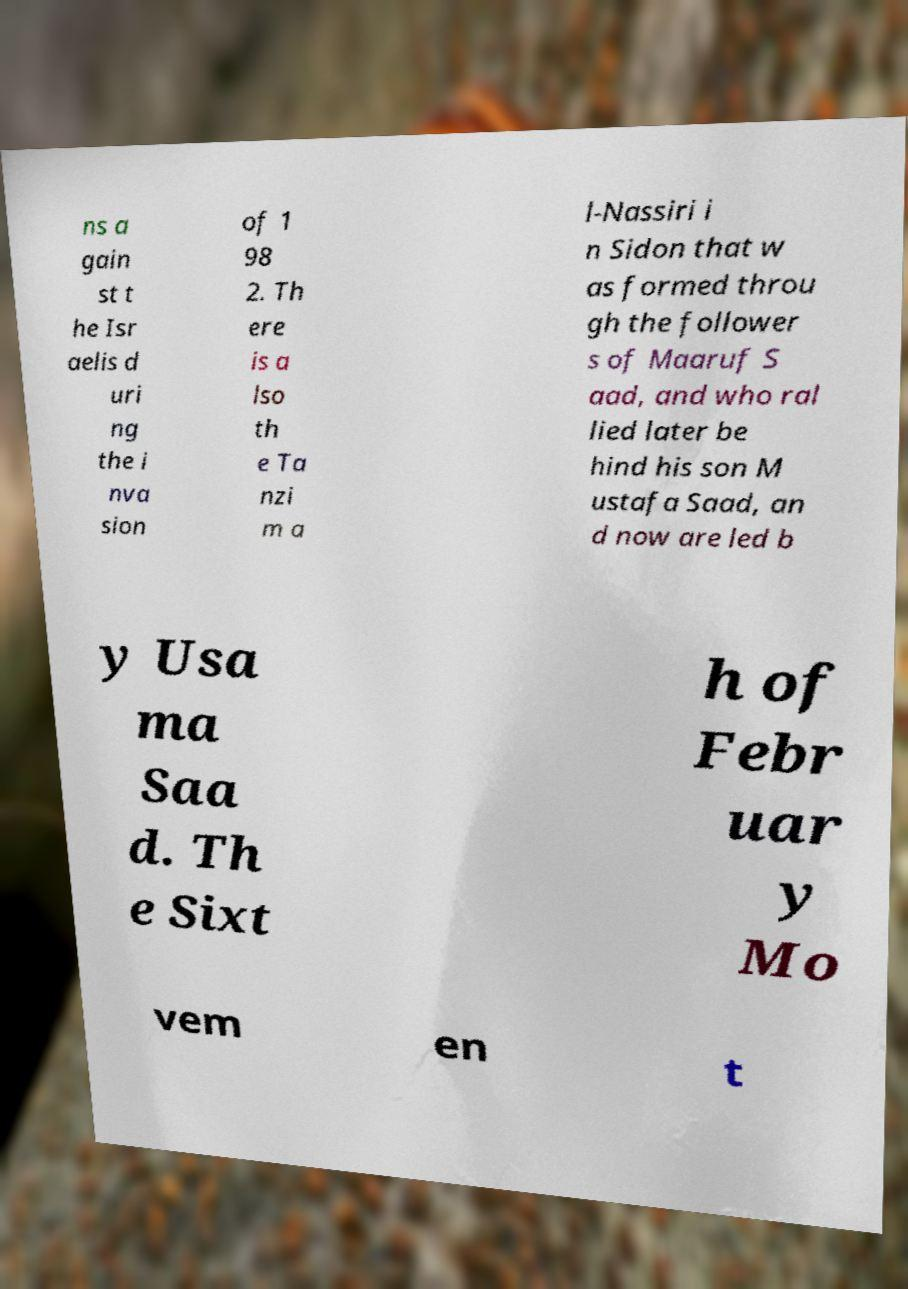Could you extract and type out the text from this image? ns a gain st t he Isr aelis d uri ng the i nva sion of 1 98 2. Th ere is a lso th e Ta nzi m a l-Nassiri i n Sidon that w as formed throu gh the follower s of Maaruf S aad, and who ral lied later be hind his son M ustafa Saad, an d now are led b y Usa ma Saa d. Th e Sixt h of Febr uar y Mo vem en t 